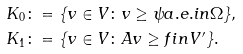<formula> <loc_0><loc_0><loc_500><loc_500>K _ { 0 } & \colon = \{ v \in V \colon v \geq \psi a . e . i n \Omega \} , \\ K _ { 1 } & \colon = \{ v \in V \colon A v \geq f i n V ^ { \prime } \} .</formula> 